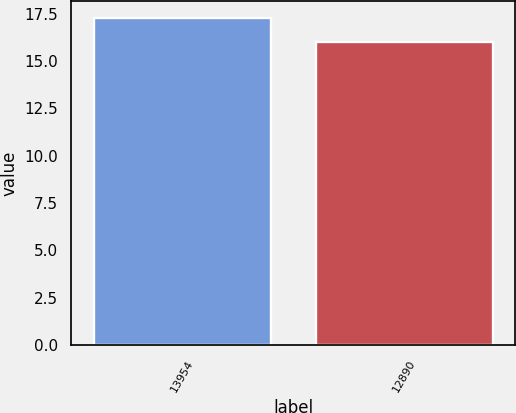Convert chart. <chart><loc_0><loc_0><loc_500><loc_500><bar_chart><fcel>13954<fcel>12890<nl><fcel>17.3<fcel>16<nl></chart> 